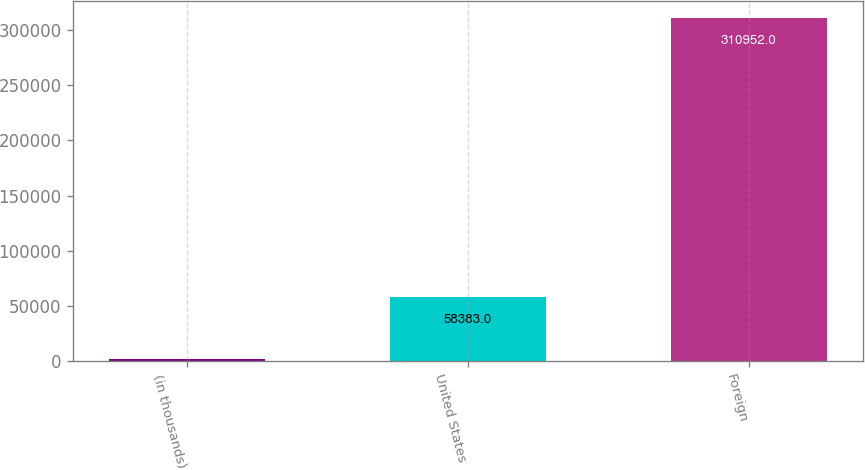Convert chart. <chart><loc_0><loc_0><loc_500><loc_500><bar_chart><fcel>(in thousands)<fcel>United States<fcel>Foreign<nl><fcel>2013<fcel>58383<fcel>310952<nl></chart> 